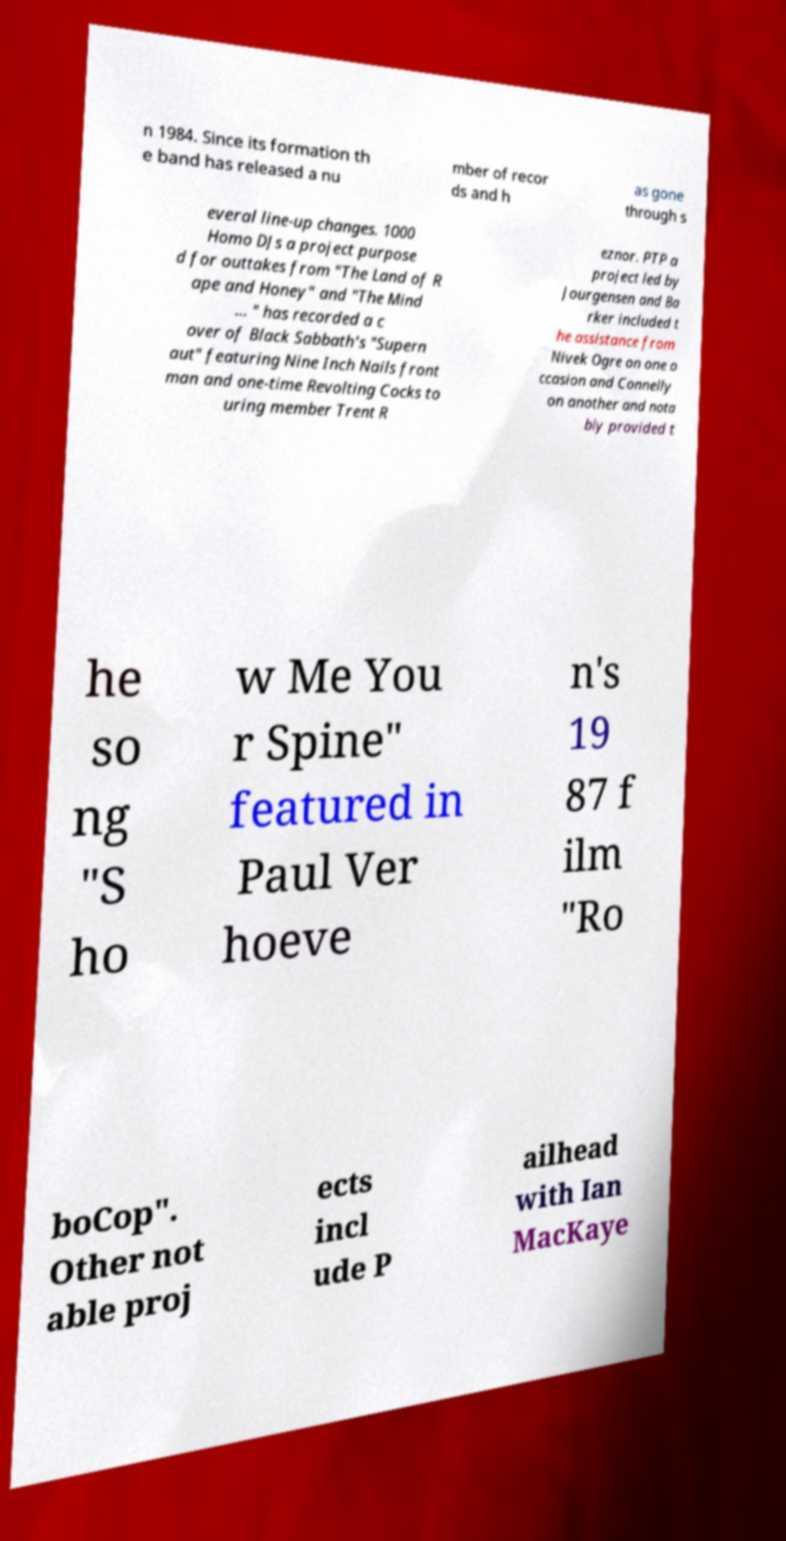Could you assist in decoding the text presented in this image and type it out clearly? n 1984. Since its formation th e band has released a nu mber of recor ds and h as gone through s everal line-up changes. 1000 Homo DJs a project purpose d for outtakes from "The Land of R ape and Honey" and "The Mind ... " has recorded a c over of Black Sabbath's "Supern aut" featuring Nine Inch Nails front man and one-time Revolting Cocks to uring member Trent R eznor. PTP a project led by Jourgensen and Ba rker included t he assistance from Nivek Ogre on one o ccasion and Connelly on another and nota bly provided t he so ng "S ho w Me You r Spine" featured in Paul Ver hoeve n's 19 87 f ilm "Ro boCop". Other not able proj ects incl ude P ailhead with Ian MacKaye 